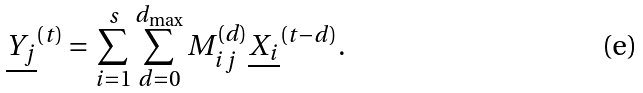Convert formula to latex. <formula><loc_0><loc_0><loc_500><loc_500>\underline { Y _ { j } } ^ { ( t ) } = \sum _ { i = 1 } ^ { s } \sum _ { d = 0 } ^ { d _ { \max } } M _ { i j } ^ { ( d ) } \underline { X _ { i } } ^ { ( t - d ) } .</formula> 